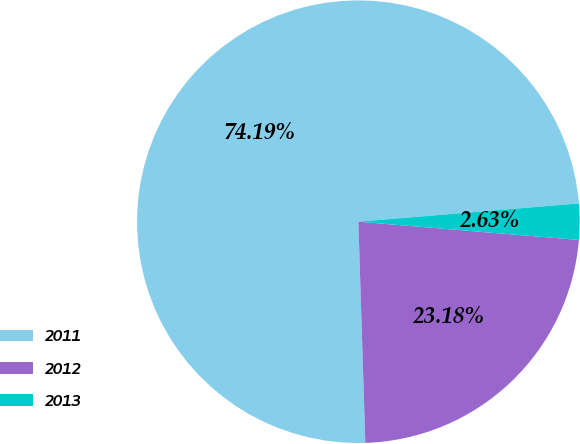Convert chart to OTSL. <chart><loc_0><loc_0><loc_500><loc_500><pie_chart><fcel>2011<fcel>2012<fcel>2013<nl><fcel>74.18%<fcel>23.18%<fcel>2.63%<nl></chart> 